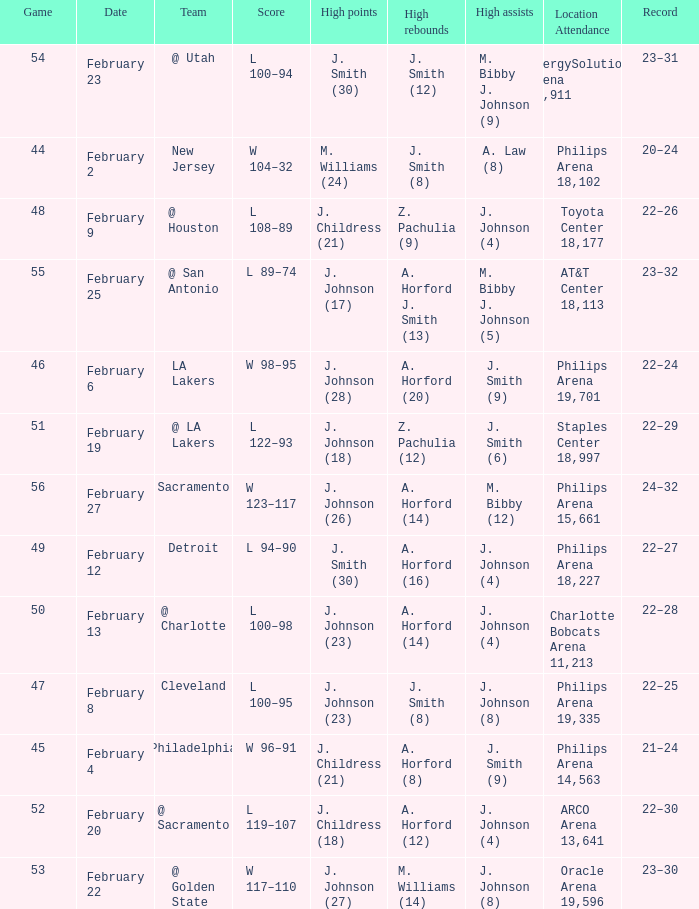Name the number of teams at the philips arena 19,335? 1.0. Would you be able to parse every entry in this table? {'header': ['Game', 'Date', 'Team', 'Score', 'High points', 'High rebounds', 'High assists', 'Location Attendance', 'Record'], 'rows': [['54', 'February 23', '@ Utah', 'L 100–94', 'J. Smith (30)', 'J. Smith (12)', 'M. Bibby J. Johnson (9)', 'EnergySolutions Arena 19,911', '23–31'], ['44', 'February 2', 'New Jersey', 'W 104–32', 'M. Williams (24)', 'J. Smith (8)', 'A. Law (8)', 'Philips Arena 18,102', '20–24'], ['48', 'February 9', '@ Houston', 'L 108–89', 'J. Childress (21)', 'Z. Pachulia (9)', 'J. Johnson (4)', 'Toyota Center 18,177', '22–26'], ['55', 'February 25', '@ San Antonio', 'L 89–74', 'J. Johnson (17)', 'A. Horford J. Smith (13)', 'M. Bibby J. Johnson (5)', 'AT&T Center 18,113', '23–32'], ['46', 'February 6', 'LA Lakers', 'W 98–95', 'J. Johnson (28)', 'A. Horford (20)', 'J. Smith (9)', 'Philips Arena 19,701', '22–24'], ['51', 'February 19', '@ LA Lakers', 'L 122–93', 'J. Johnson (18)', 'Z. Pachulia (12)', 'J. Smith (6)', 'Staples Center 18,997', '22–29'], ['56', 'February 27', 'Sacramento', 'W 123–117', 'J. Johnson (26)', 'A. Horford (14)', 'M. Bibby (12)', 'Philips Arena 15,661', '24–32'], ['49', 'February 12', 'Detroit', 'L 94–90', 'J. Smith (30)', 'A. Horford (16)', 'J. Johnson (4)', 'Philips Arena 18,227', '22–27'], ['50', 'February 13', '@ Charlotte', 'L 100–98', 'J. Johnson (23)', 'A. Horford (14)', 'J. Johnson (4)', 'Charlotte Bobcats Arena 11,213', '22–28'], ['47', 'February 8', 'Cleveland', 'L 100–95', 'J. Johnson (23)', 'J. Smith (8)', 'J. Johnson (8)', 'Philips Arena 19,335', '22–25'], ['45', 'February 4', 'Philadelphia', 'W 96–91', 'J. Childress (21)', 'A. Horford (8)', 'J. Smith (9)', 'Philips Arena 14,563', '21–24'], ['52', 'February 20', '@ Sacramento', 'L 119–107', 'J. Childress (18)', 'A. Horford (12)', 'J. Johnson (4)', 'ARCO Arena 13,641', '22–30'], ['53', 'February 22', '@ Golden State', 'W 117–110', 'J. Johnson (27)', 'M. Williams (14)', 'J. Johnson (8)', 'Oracle Arena 19,596', '23–30']]} 